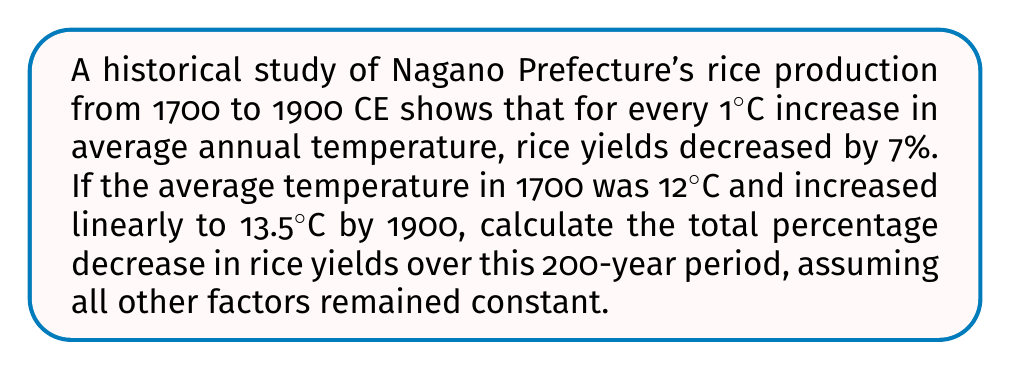Can you answer this question? 1. Calculate the total temperature increase:
   $\Delta T = 13.5°C - 12°C = 1.5°C$

2. Calculate the yield decrease per 1°C:
   Yield decrease = 7% per 1°C

3. Calculate the total yield decrease:
   Total yield decrease = $1.5 \times 7\% = 10.5\%$

4. The formula for the final yield as a percentage of the initial yield:
   $$Y_f = Y_i \times (1 - 0.105)$$
   Where $Y_f$ is the final yield and $Y_i$ is the initial yield

5. Calculate the percentage of the initial yield remaining:
   $1 - 0.105 = 0.895$ or $89.5\%$

6. Calculate the total percentage decrease:
   Total percentage decrease = $100\% - 89.5\% = 10.5\%$
Answer: 10.5% 